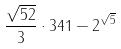Convert formula to latex. <formula><loc_0><loc_0><loc_500><loc_500>\frac { \sqrt { 5 2 } } { 3 } \cdot 3 4 1 - 2 ^ { \sqrt { 5 } }</formula> 